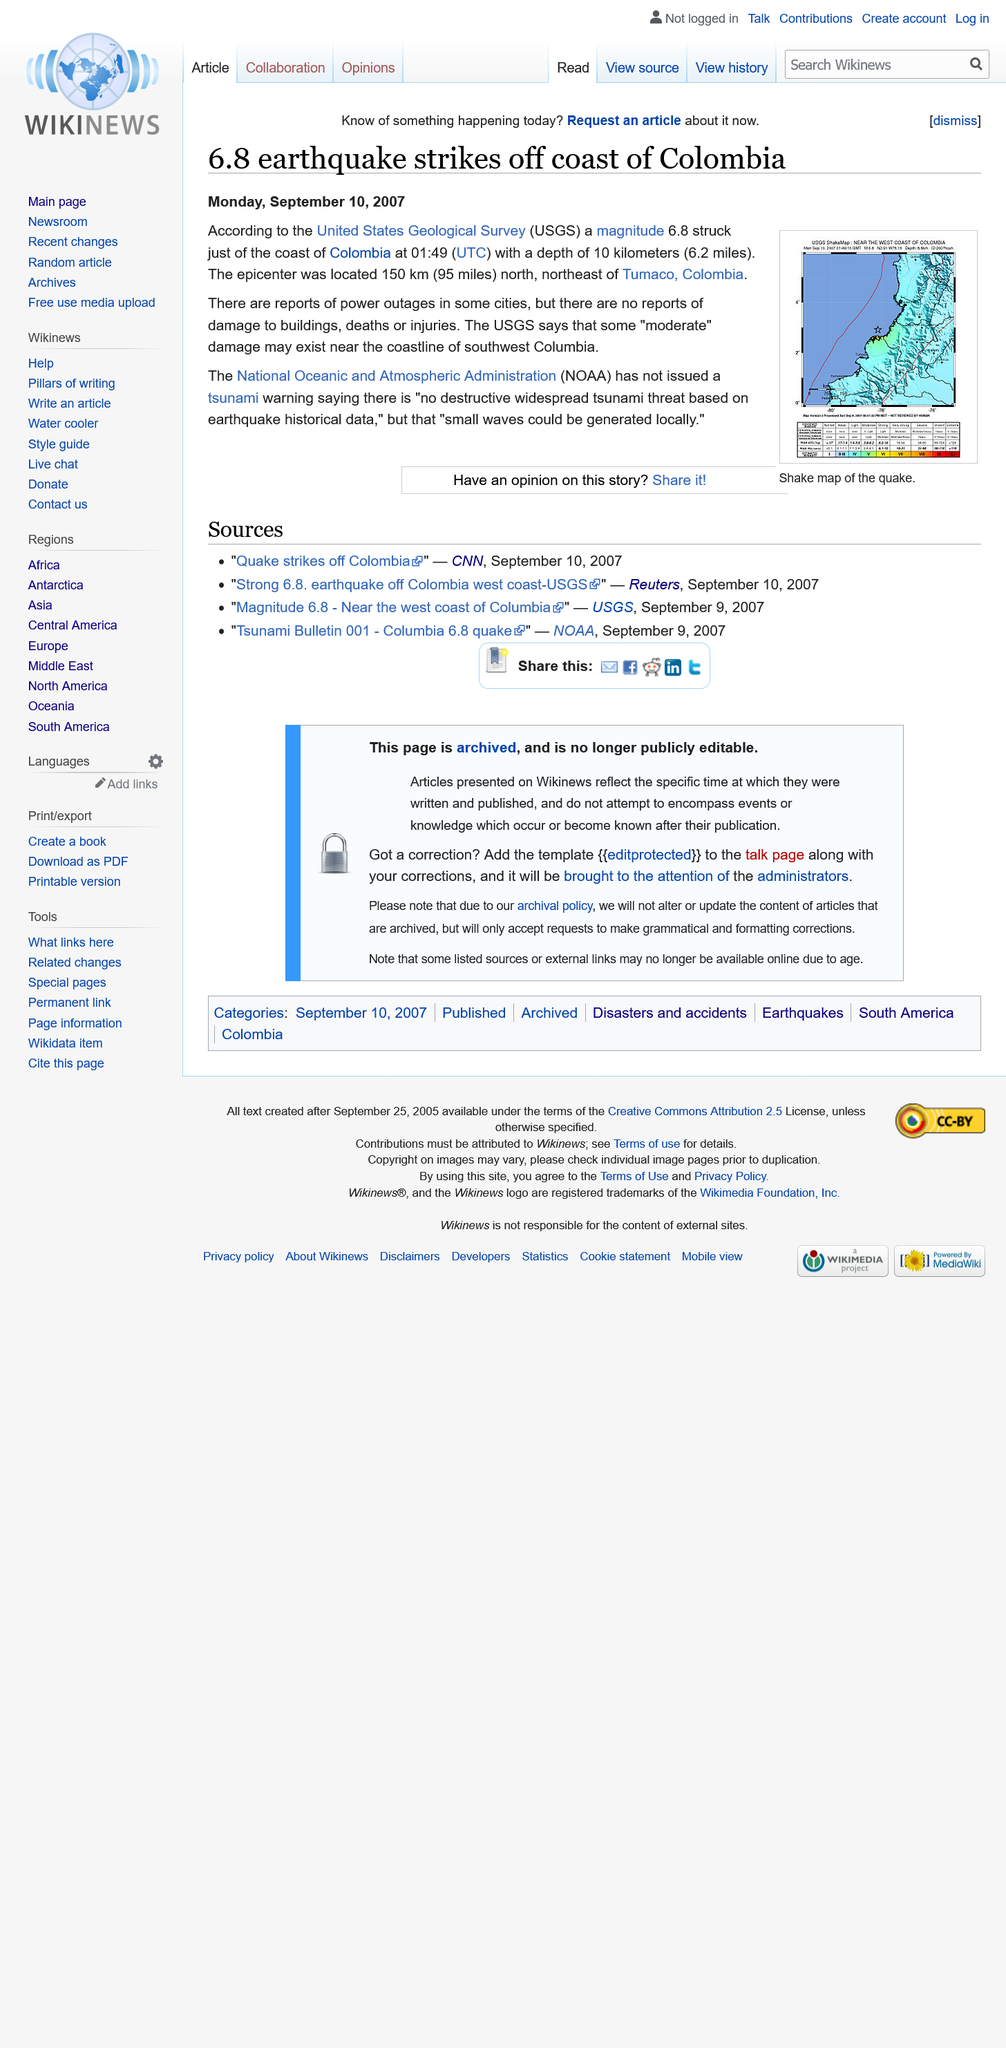Draw attention to some important aspects in this diagram. On Monday, September 10th, 2007, a 6.8 earthquake struck off the coast of Colombia at 01:49 (UTC). I am unable to complete your request. Could you please provide more information about the context or purpose of the sentence you would like me to convert? The USGS has declared that the damage caused by the earthquake off the coast of Colombia is "moderate. 